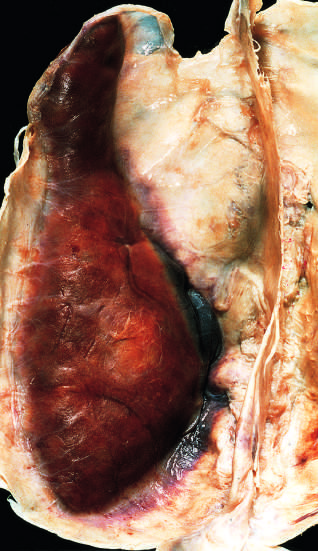s gross appearance of leukoplakia attached to the dura?
Answer the question using a single word or phrase. No 